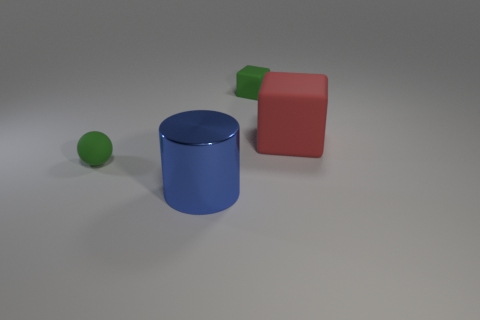Subtract all purple spheres. Subtract all purple cubes. How many spheres are left? 1 Add 2 tiny green rubber spheres. How many objects exist? 6 Subtract all spheres. How many objects are left? 3 Add 1 green cubes. How many green cubes exist? 2 Subtract 0 yellow cylinders. How many objects are left? 4 Subtract all tiny gray cylinders. Subtract all red rubber things. How many objects are left? 3 Add 2 small rubber blocks. How many small rubber blocks are left? 3 